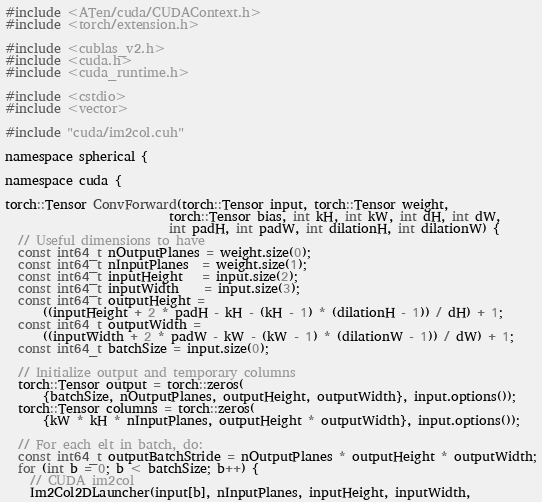<code> <loc_0><loc_0><loc_500><loc_500><_Cuda_>#include <ATen/cuda/CUDAContext.h>
#include <torch/extension.h>

#include <cublas_v2.h>
#include <cuda.h>
#include <cuda_runtime.h>

#include <cstdio>
#include <vector>

#include "cuda/im2col.cuh"

namespace spherical {

namespace cuda {

torch::Tensor ConvForward(torch::Tensor input, torch::Tensor weight,
                          torch::Tensor bias, int kH, int kW, int dH, int dW,
                          int padH, int padW, int dilationH, int dilationW) {
  // Useful dimensions to have
  const int64_t nOutputPlanes = weight.size(0);
  const int64_t nInputPlanes  = weight.size(1);
  const int64_t inputHeight   = input.size(2);
  const int64_t inputWidth    = input.size(3);
  const int64_t outputHeight =
      ((inputHeight + 2 * padH - kH - (kH - 1) * (dilationH - 1)) / dH) + 1;
  const int64_t outputWidth =
      ((inputWidth + 2 * padW - kW - (kW - 1) * (dilationW - 1)) / dW) + 1;
  const int64_t batchSize = input.size(0);

  // Initialize output and temporary columns
  torch::Tensor output = torch::zeros(
      {batchSize, nOutputPlanes, outputHeight, outputWidth}, input.options());
  torch::Tensor columns = torch::zeros(
      {kW * kH * nInputPlanes, outputHeight * outputWidth}, input.options());

  // For each elt in batch, do:
  const int64_t outputBatchStride = nOutputPlanes * outputHeight * outputWidth;
  for (int b = 0; b < batchSize; b++) {
    // CUDA im2col
    Im2Col2DLauncher(input[b], nInputPlanes, inputHeight, inputWidth,</code> 